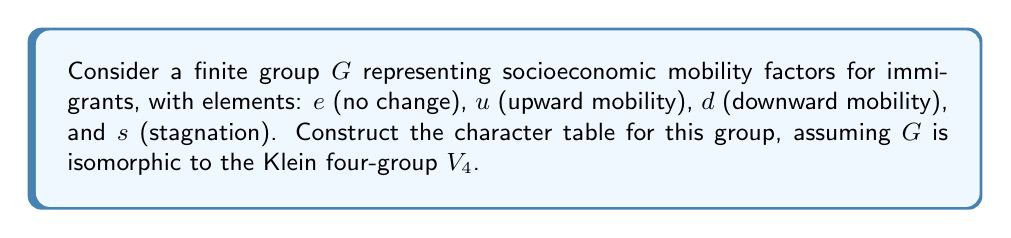Can you answer this question? 1) First, identify the conjugacy classes of $G$:
   Since $G \cong V_4$, each element forms its own conjugacy class: $\{e\}, \{u\}, \{d\}, \{s\}$

2) Determine the number of irreducible representations:
   The number of irreducible representations equals the number of conjugacy classes, which is 4.

3) The dimensions of these representations must satisfy:
   $1^2 + 1^2 + 1^2 + 1^2 = 4$ (order of the group)
   So, all irreducible representations are 1-dimensional.

4) Construct the character table:
   - The first row (trivial representation) is always all 1's.
   - For the remaining rows, we need characters that satisfy orthogonality relations.
   - Since $G \cong V_4$, we can use the character table of $V_4$ as a template:

   $$
   \begin{array}{c|cccc}
    G & e & u & d & s \\
    \hline
    \chi_1 & 1 & 1 & 1 & 1 \\
    \chi_2 & 1 & 1 & -1 & -1 \\
    \chi_3 & 1 & -1 & 1 & -1 \\
    \chi_4 & 1 & -1 & -1 & 1
   \end{array}
   $$

5) Interpret the characters:
   - $\chi_1$: Trivial representation (no change in socioeconomic status)
   - $\chi_2$: Distinguishes between upward/no change and downward/stagnation
   - $\chi_3$: Distinguishes between upward/downward and no change/stagnation
   - $\chi_4$: Distinguishes between upward/stagnation and no change/downward

This character table reflects how different aspects of socioeconomic mobility can be represented for immigrant populations.
Answer: $$
\begin{array}{c|cccc}
G & e & u & d & s \\
\hline
\chi_1 & 1 & 1 & 1 & 1 \\
\chi_2 & 1 & 1 & -1 & -1 \\
\chi_3 & 1 & -1 & 1 & -1 \\
\chi_4 & 1 & -1 & -1 & 1
\end{array}
$$ 